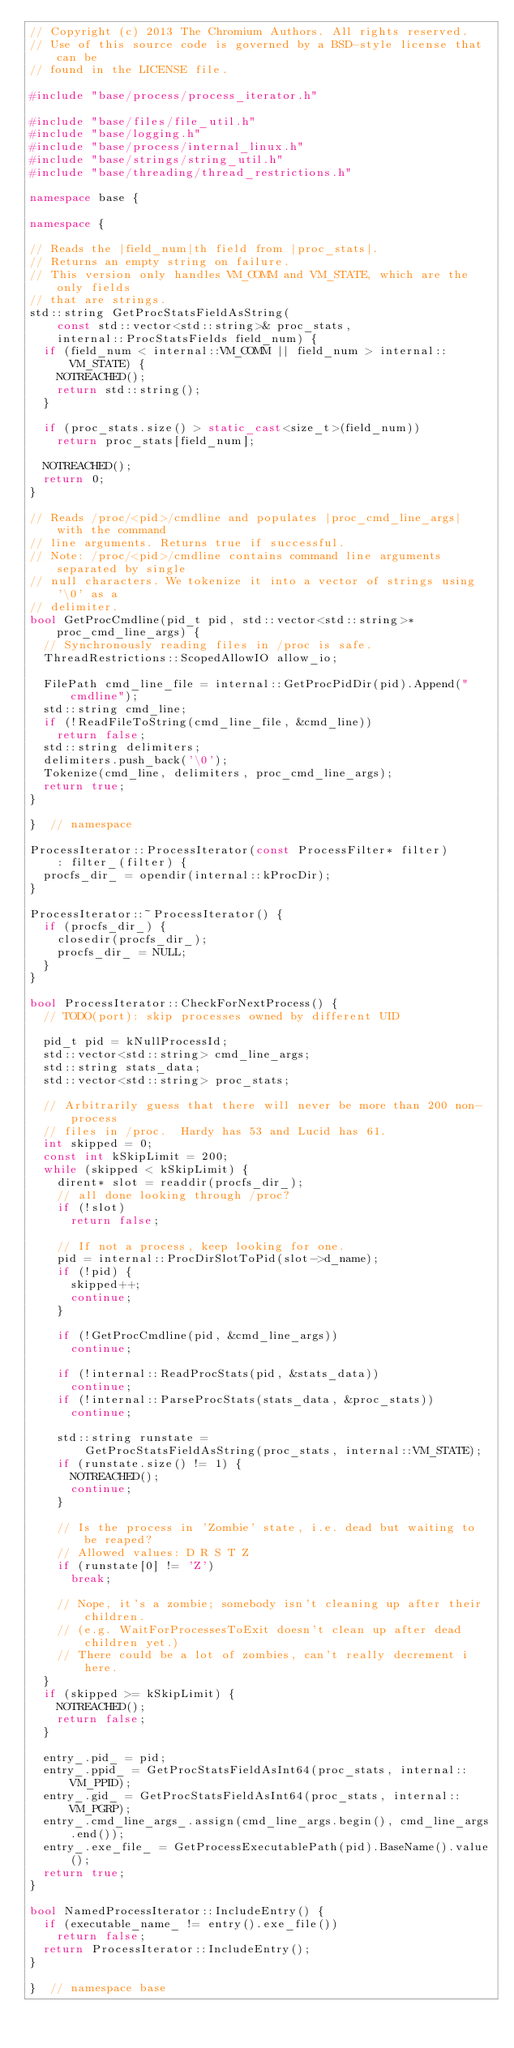Convert code to text. <code><loc_0><loc_0><loc_500><loc_500><_C++_>// Copyright (c) 2013 The Chromium Authors. All rights reserved.
// Use of this source code is governed by a BSD-style license that can be
// found in the LICENSE file.

#include "base/process/process_iterator.h"

#include "base/files/file_util.h"
#include "base/logging.h"
#include "base/process/internal_linux.h"
#include "base/strings/string_util.h"
#include "base/threading/thread_restrictions.h"

namespace base {

namespace {

// Reads the |field_num|th field from |proc_stats|.
// Returns an empty string on failure.
// This version only handles VM_COMM and VM_STATE, which are the only fields
// that are strings.
std::string GetProcStatsFieldAsString(
    const std::vector<std::string>& proc_stats,
    internal::ProcStatsFields field_num) {
  if (field_num < internal::VM_COMM || field_num > internal::VM_STATE) {
    NOTREACHED();
    return std::string();
  }

  if (proc_stats.size() > static_cast<size_t>(field_num))
    return proc_stats[field_num];

  NOTREACHED();
  return 0;
}

// Reads /proc/<pid>/cmdline and populates |proc_cmd_line_args| with the command
// line arguments. Returns true if successful.
// Note: /proc/<pid>/cmdline contains command line arguments separated by single
// null characters. We tokenize it into a vector of strings using '\0' as a
// delimiter.
bool GetProcCmdline(pid_t pid, std::vector<std::string>* proc_cmd_line_args) {
  // Synchronously reading files in /proc is safe.
  ThreadRestrictions::ScopedAllowIO allow_io;

  FilePath cmd_line_file = internal::GetProcPidDir(pid).Append("cmdline");
  std::string cmd_line;
  if (!ReadFileToString(cmd_line_file, &cmd_line))
    return false;
  std::string delimiters;
  delimiters.push_back('\0');
  Tokenize(cmd_line, delimiters, proc_cmd_line_args);
  return true;
}

}  // namespace

ProcessIterator::ProcessIterator(const ProcessFilter* filter)
    : filter_(filter) {
  procfs_dir_ = opendir(internal::kProcDir);
}

ProcessIterator::~ProcessIterator() {
  if (procfs_dir_) {
    closedir(procfs_dir_);
    procfs_dir_ = NULL;
  }
}

bool ProcessIterator::CheckForNextProcess() {
  // TODO(port): skip processes owned by different UID

  pid_t pid = kNullProcessId;
  std::vector<std::string> cmd_line_args;
  std::string stats_data;
  std::vector<std::string> proc_stats;

  // Arbitrarily guess that there will never be more than 200 non-process
  // files in /proc.  Hardy has 53 and Lucid has 61.
  int skipped = 0;
  const int kSkipLimit = 200;
  while (skipped < kSkipLimit) {
    dirent* slot = readdir(procfs_dir_);
    // all done looking through /proc?
    if (!slot)
      return false;

    // If not a process, keep looking for one.
    pid = internal::ProcDirSlotToPid(slot->d_name);
    if (!pid) {
      skipped++;
      continue;
    }

    if (!GetProcCmdline(pid, &cmd_line_args))
      continue;

    if (!internal::ReadProcStats(pid, &stats_data))
      continue;
    if (!internal::ParseProcStats(stats_data, &proc_stats))
      continue;

    std::string runstate =
        GetProcStatsFieldAsString(proc_stats, internal::VM_STATE);
    if (runstate.size() != 1) {
      NOTREACHED();
      continue;
    }

    // Is the process in 'Zombie' state, i.e. dead but waiting to be reaped?
    // Allowed values: D R S T Z
    if (runstate[0] != 'Z')
      break;

    // Nope, it's a zombie; somebody isn't cleaning up after their children.
    // (e.g. WaitForProcessesToExit doesn't clean up after dead children yet.)
    // There could be a lot of zombies, can't really decrement i here.
  }
  if (skipped >= kSkipLimit) {
    NOTREACHED();
    return false;
  }

  entry_.pid_ = pid;
  entry_.ppid_ = GetProcStatsFieldAsInt64(proc_stats, internal::VM_PPID);
  entry_.gid_ = GetProcStatsFieldAsInt64(proc_stats, internal::VM_PGRP);
  entry_.cmd_line_args_.assign(cmd_line_args.begin(), cmd_line_args.end());
  entry_.exe_file_ = GetProcessExecutablePath(pid).BaseName().value();
  return true;
}

bool NamedProcessIterator::IncludeEntry() {
  if (executable_name_ != entry().exe_file())
    return false;
  return ProcessIterator::IncludeEntry();
}

}  // namespace base
</code> 